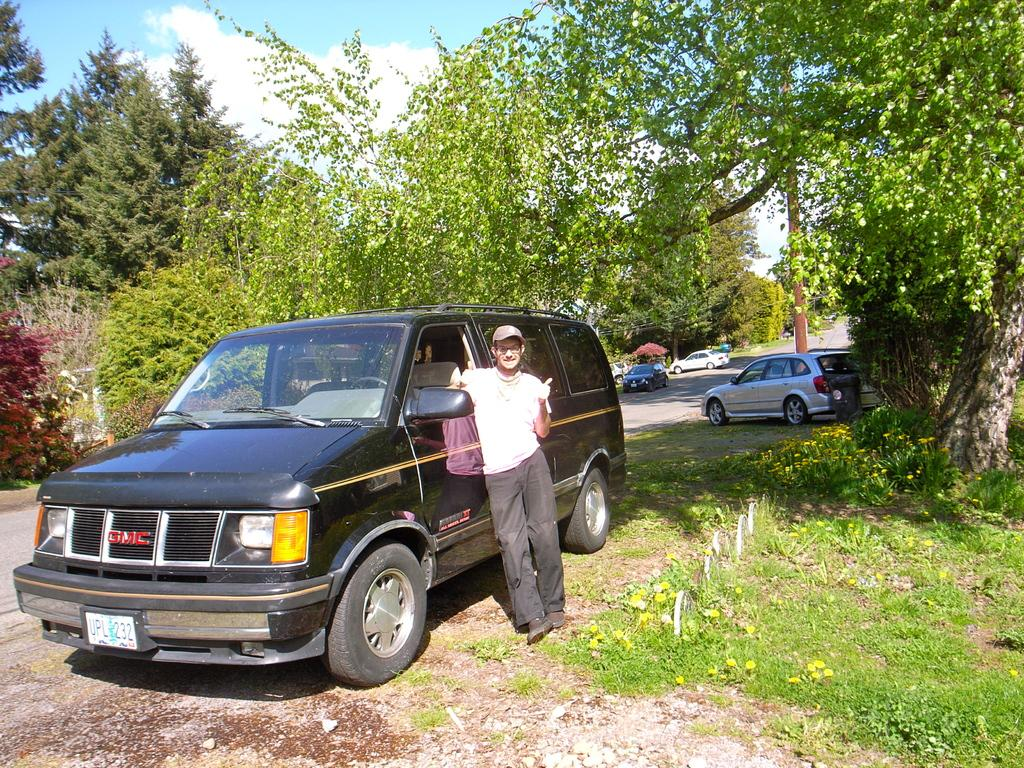What is the main subject of the image? There is a person standing in the image. What can be seen on the path in the image? There are cars on the path in the image. What type of natural elements are visible in the background of the image? There are trees and plants in the background of the image. What is the condition of the sky in the image? The sky is blue and cloudy in the image. Can you tell me how many boys are twisting in the image? There are no boys twisting in the image; it features a person standing and other elements mentioned in the conversation. 